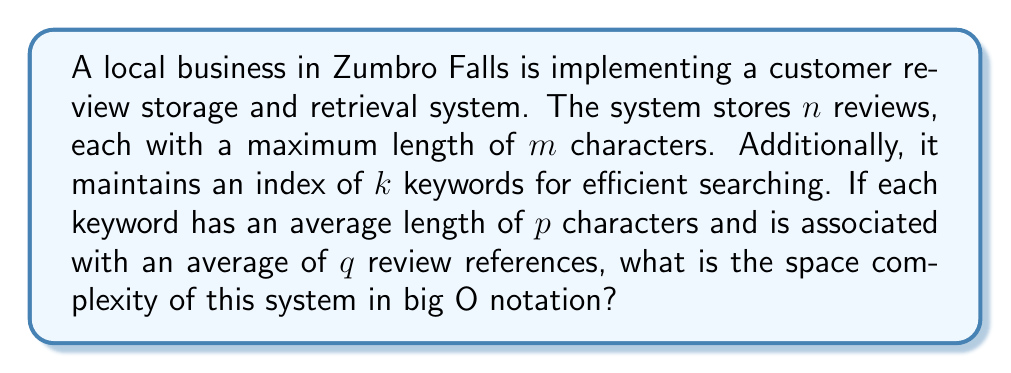Help me with this question. Let's break down the space requirements for each component of the system:

1. Review storage:
   - There are $n$ reviews
   - Each review has a maximum length of $m$ characters
   - Space required: $O(n \cdot m)$

2. Keyword index:
   - There are $k$ keywords
   - Each keyword has an average length of $p$ characters
   - Space for keywords: $O(k \cdot p)$

3. Review references for keywords:
   - Each keyword is associated with an average of $q$ review references
   - Assuming each reference is stored as an integer (constant space)
   - Space for references: $O(k \cdot q)$

Total space complexity:
$$O(n \cdot m + k \cdot p + k \cdot q)$$

We can simplify this expression:
- $k \cdot p$ and $k \cdot q$ can be combined as $k \cdot (p + q)$
- Since $p$ and $q$ are typically much smaller than $m$ or $n$, we can consider them as constants

This gives us:
$$O(n \cdot m + k)$$

In most practical scenarios, the number of keywords $k$ would be significantly smaller than the total size of all reviews $n \cdot m$. Therefore, we can further simplify the expression to:

$$O(n \cdot m)$$

This represents the dominant term in the space complexity analysis.
Answer: $O(n \cdot m)$ 